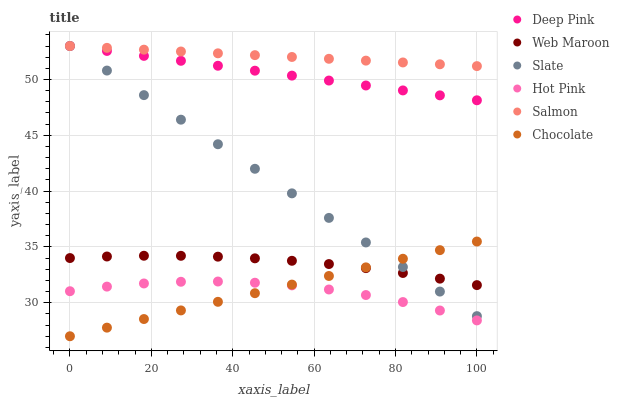Does Hot Pink have the minimum area under the curve?
Answer yes or no. Yes. Does Salmon have the maximum area under the curve?
Answer yes or no. Yes. Does Web Maroon have the minimum area under the curve?
Answer yes or no. No. Does Web Maroon have the maximum area under the curve?
Answer yes or no. No. Is Chocolate the smoothest?
Answer yes or no. Yes. Is Hot Pink the roughest?
Answer yes or no. Yes. Is Web Maroon the smoothest?
Answer yes or no. No. Is Web Maroon the roughest?
Answer yes or no. No. Does Chocolate have the lowest value?
Answer yes or no. Yes. Does Web Maroon have the lowest value?
Answer yes or no. No. Does Salmon have the highest value?
Answer yes or no. Yes. Does Web Maroon have the highest value?
Answer yes or no. No. Is Web Maroon less than Deep Pink?
Answer yes or no. Yes. Is Deep Pink greater than Web Maroon?
Answer yes or no. Yes. Does Deep Pink intersect Slate?
Answer yes or no. Yes. Is Deep Pink less than Slate?
Answer yes or no. No. Is Deep Pink greater than Slate?
Answer yes or no. No. Does Web Maroon intersect Deep Pink?
Answer yes or no. No. 